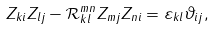Convert formula to latex. <formula><loc_0><loc_0><loc_500><loc_500>Z _ { k i } Z _ { l j } - \mathcal { R } _ { k l } ^ { m n } Z _ { m j } Z _ { n i } = \varepsilon _ { k l } \vartheta _ { i j } ,</formula> 